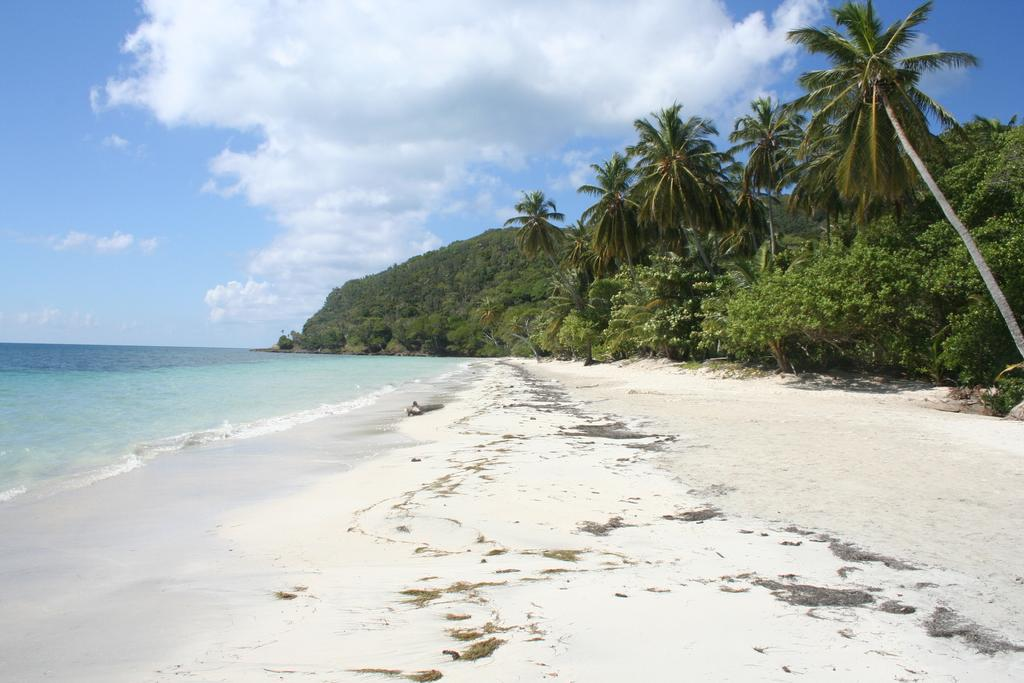What type of location is shown in the image? The image depicts a beach. What can be seen on the right side of the image? There is a group of trees on the right side of the image. What is visible at the top of the image? The sky is clear and visible at the top of the image. What type of fiction is being read by the birds in the image? There are no birds or fiction present in the image; it depicts a beach with a group of trees and a clear sky. 